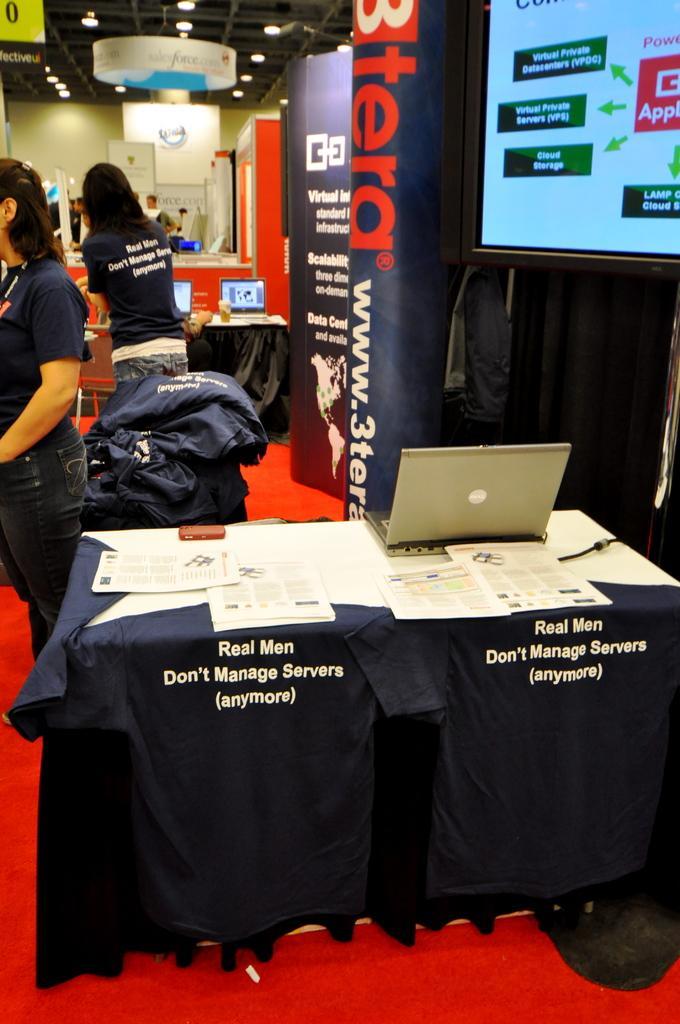Could you give a brief overview of what you see in this image? In this image we can see tablecloths, laptops, papers, screen, hoardings, boards, and people. In the background we can see wall, ceiling, and lights. 